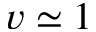<formula> <loc_0><loc_0><loc_500><loc_500>v \simeq 1</formula> 